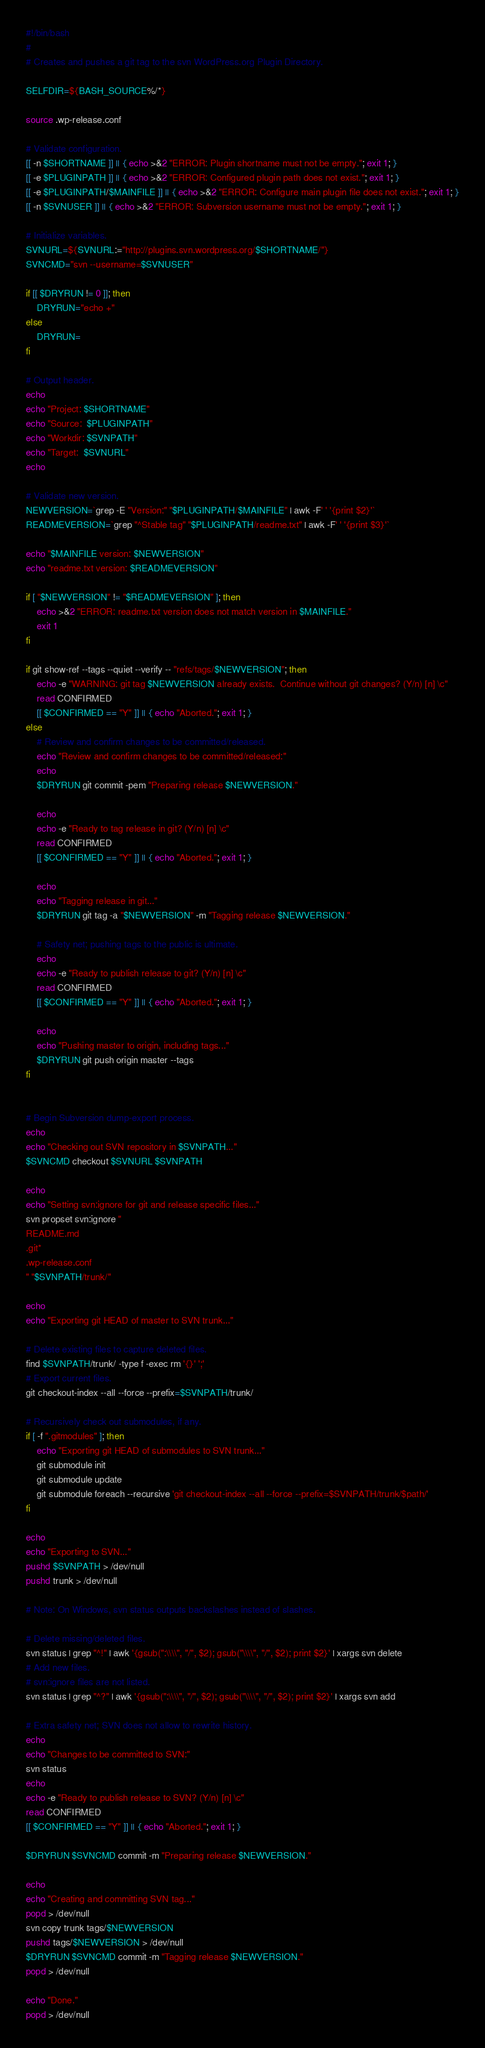<code> <loc_0><loc_0><loc_500><loc_500><_Bash_>#!/bin/bash
#
# Creates and pushes a git tag to the svn WordPress.org Plugin Directory.

SELFDIR=${BASH_SOURCE%/*}

source .wp-release.conf

# Validate configuration.
[[ -n $SHORTNAME ]] || { echo >&2 "ERROR: Plugin shortname must not be empty."; exit 1; }
[[ -e $PLUGINPATH ]] || { echo >&2 "ERROR: Configured plugin path does not exist."; exit 1; }
[[ -e $PLUGINPATH/$MAINFILE ]] || { echo >&2 "ERROR: Configure main plugin file does not exist."; exit 1; }
[[ -n $SVNUSER ]] || { echo >&2 "ERROR: Subversion username must not be empty."; exit 1; }

# Initialize variables.
SVNURL=${SVNURL:="http://plugins.svn.wordpress.org/$SHORTNAME/"}
SVNCMD="svn --username=$SVNUSER"

if [[ $DRYRUN != 0 ]]; then
	DRYRUN="echo +"
else
	DRYRUN=
fi

# Output header.
echo
echo "Project: $SHORTNAME"
echo "Source:  $PLUGINPATH"
echo "Workdir: $SVNPATH"
echo "Target:  $SVNURL"
echo

# Validate new version.
NEWVERSION=`grep -E "Version:" "$PLUGINPATH/$MAINFILE" | awk -F' ' '{print $2}'`
READMEVERSION=`grep "^Stable tag" "$PLUGINPATH/readme.txt" | awk -F' ' '{print $3}'`

echo "$MAINFILE version: $NEWVERSION"
echo "readme.txt version: $READMEVERSION"

if [ "$NEWVERSION" != "$READMEVERSION" ]; then
	echo >&2 "ERROR: readme.txt version does not match version in $MAINFILE."
	exit 1
fi

if git show-ref --tags --quiet --verify -- "refs/tags/$NEWVERSION"; then
	echo -e "WARNING: git tag $NEWVERSION already exists.  Continue without git changes? (Y/n) [n] \c"
	read CONFIRMED
	[[ $CONFIRMED == "Y" ]] || { echo "Aborted."; exit 1; }
else
	# Review and confirm changes to be committed/released.
	echo "Review and confirm changes to be committed/released:"
	echo
	$DRYRUN git commit -pem "Preparing release $NEWVERSION."

	echo
	echo -e "Ready to tag release in git? (Y/n) [n] \c"
	read CONFIRMED
	[[ $CONFIRMED == "Y" ]] || { echo "Aborted."; exit 1; }

	echo
	echo "Tagging release in git..."
	$DRYRUN git tag -a "$NEWVERSION" -m "Tagging release $NEWVERSION."

	# Safety net; pushing tags to the public is ultimate.
	echo
	echo -e "Ready to publish release to git? (Y/n) [n] \c"
	read CONFIRMED
	[[ $CONFIRMED == "Y" ]] || { echo "Aborted."; exit 1; }

	echo
	echo "Pushing master to origin, including tags..."
	$DRYRUN git push origin master --tags
fi


# Begin Subversion dump-export process.
echo
echo "Checking out SVN repository in $SVNPATH..."
$SVNCMD checkout $SVNURL $SVNPATH

echo
echo "Setting svn:ignore for git and release specific files..."
svn propset svn:ignore "
README.md
.git*
.wp-release.conf
" "$SVNPATH/trunk/"

echo
echo "Exporting git HEAD of master to SVN trunk..."

# Delete existing files to capture deleted files.
find $SVNPATH/trunk/ -type f -exec rm '{}' ';'
# Export current files.
git checkout-index --all --force --prefix=$SVNPATH/trunk/

# Recursively check out submodules, if any.
if [ -f ".gitmodules" ]; then
	echo "Exporting git HEAD of submodules to SVN trunk..."
	git submodule init
	git submodule update
	git submodule foreach --recursive 'git checkout-index --all --force --prefix=$SVNPATH/trunk/$path/'
fi

echo
echo "Exporting to SVN..."
pushd $SVNPATH > /dev/null
pushd trunk > /dev/null

# Note: On Windows, svn status outputs backslashes instead of slashes.

# Delete missing/deleted files.
svn status | grep "^!" | awk '{gsub(":\\\\", "/", $2); gsub("\\\\", "/", $2); print $2}' | xargs svn delete
# Add new files.
# svn:ignore files are not listed.
svn status | grep "^?" | awk '{gsub(":\\\\", "/", $2); gsub("\\\\", "/", $2); print $2}' | xargs svn add

# Extra safety net; SVN does not allow to rewrite history.
echo
echo "Changes to be committed to SVN:"
svn status
echo
echo -e "Ready to publish release to SVN? (Y/n) [n] \c"
read CONFIRMED
[[ $CONFIRMED == "Y" ]] || { echo "Aborted."; exit 1; }

$DRYRUN $SVNCMD commit -m "Preparing release $NEWVERSION."

echo
echo "Creating and committing SVN tag..."
popd > /dev/null
svn copy trunk tags/$NEWVERSION
pushd tags/$NEWVERSION > /dev/null
$DRYRUN $SVNCMD commit -m "Tagging release $NEWVERSION."
popd > /dev/null

echo "Done."
popd > /dev/null
</code> 